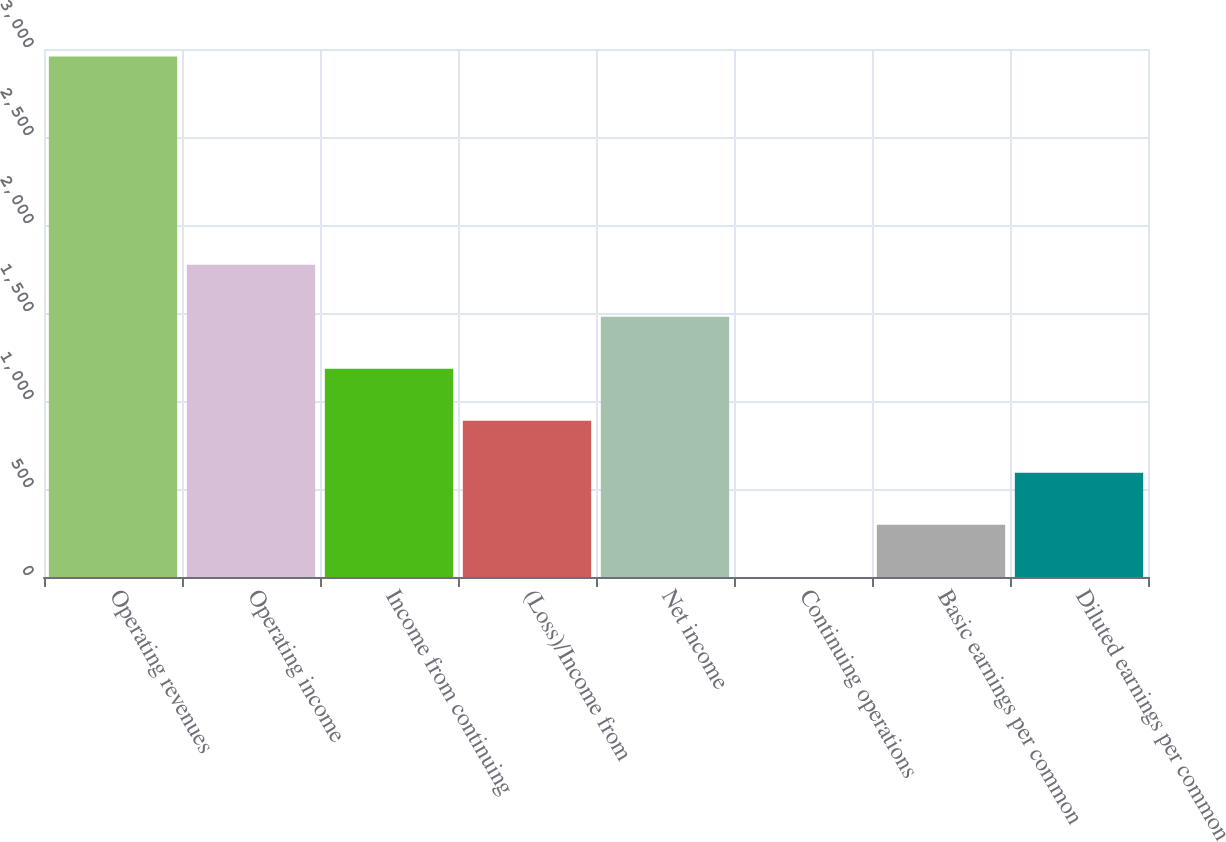Convert chart. <chart><loc_0><loc_0><loc_500><loc_500><bar_chart><fcel>Operating revenues<fcel>Operating income<fcel>Income from continuing<fcel>(Loss)/Income from<fcel>Net income<fcel>Continuing operations<fcel>Basic earnings per common<fcel>Diluted earnings per common<nl><fcel>2957<fcel>1774.41<fcel>1183.13<fcel>887.49<fcel>1478.77<fcel>0.57<fcel>296.21<fcel>591.85<nl></chart> 